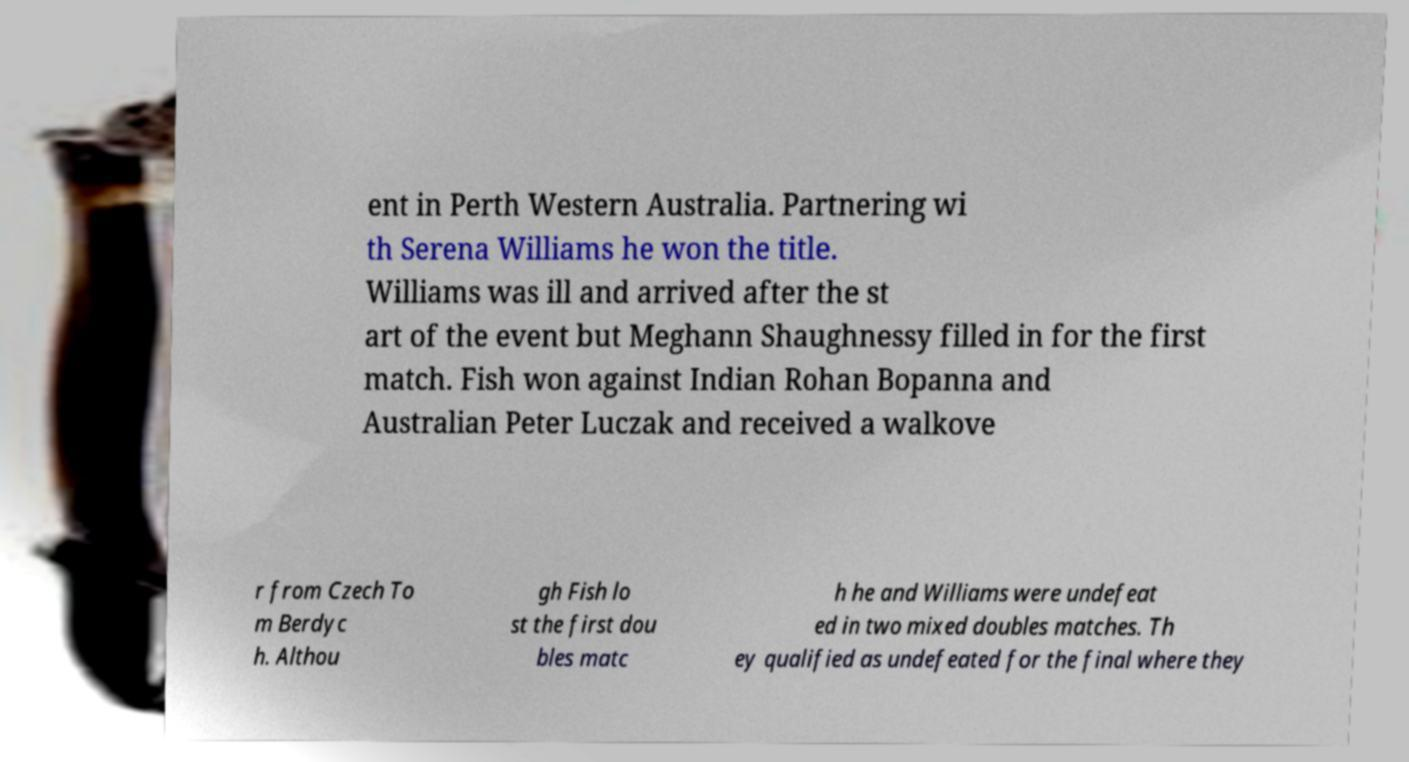Can you read and provide the text displayed in the image?This photo seems to have some interesting text. Can you extract and type it out for me? ent in Perth Western Australia. Partnering wi th Serena Williams he won the title. Williams was ill and arrived after the st art of the event but Meghann Shaughnessy filled in for the first match. Fish won against Indian Rohan Bopanna and Australian Peter Luczak and received a walkove r from Czech To m Berdyc h. Althou gh Fish lo st the first dou bles matc h he and Williams were undefeat ed in two mixed doubles matches. Th ey qualified as undefeated for the final where they 